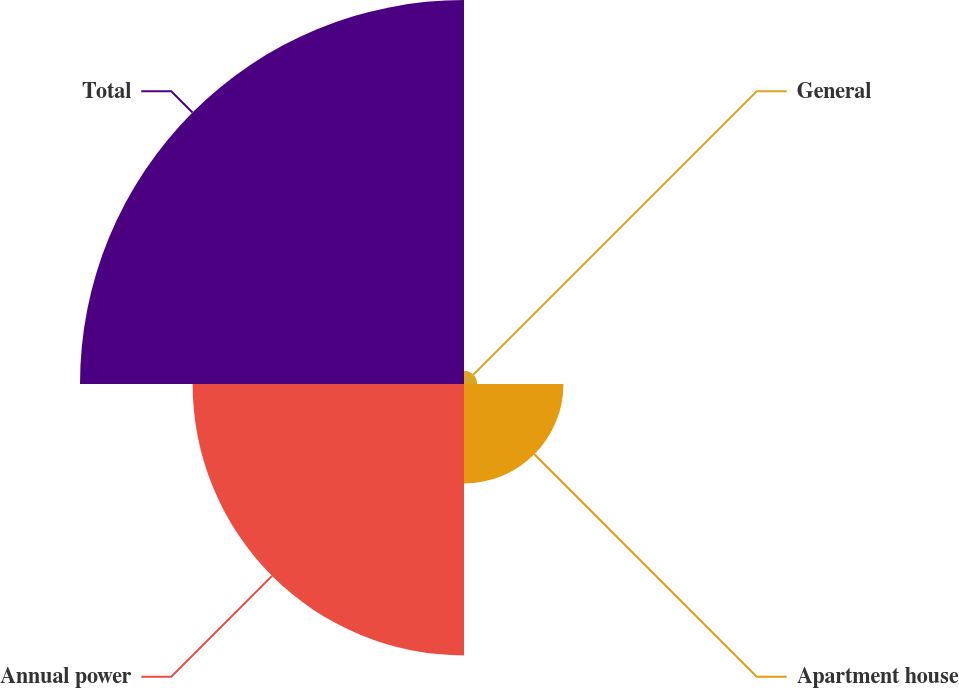Convert chart to OTSL. <chart><loc_0><loc_0><loc_500><loc_500><pie_chart><fcel>General<fcel>Apartment house<fcel>Annual power<fcel>Total<nl><fcel>1.71%<fcel>12.95%<fcel>35.34%<fcel>50.0%<nl></chart> 